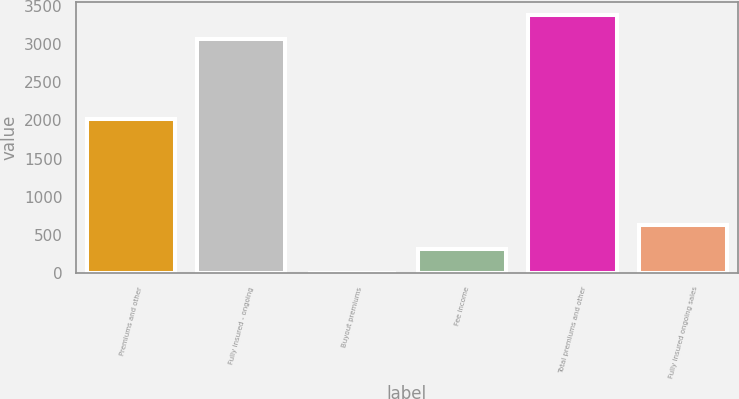Convert chart to OTSL. <chart><loc_0><loc_0><loc_500><loc_500><bar_chart><fcel>Premiums and other<fcel>Fully insured - ongoing<fcel>Buyout premiums<fcel>Fee income<fcel>Total premiums and other<fcel>Fully insured ongoing sales<nl><fcel>2015<fcel>3068<fcel>1<fcel>314.5<fcel>3381.5<fcel>628<nl></chart> 